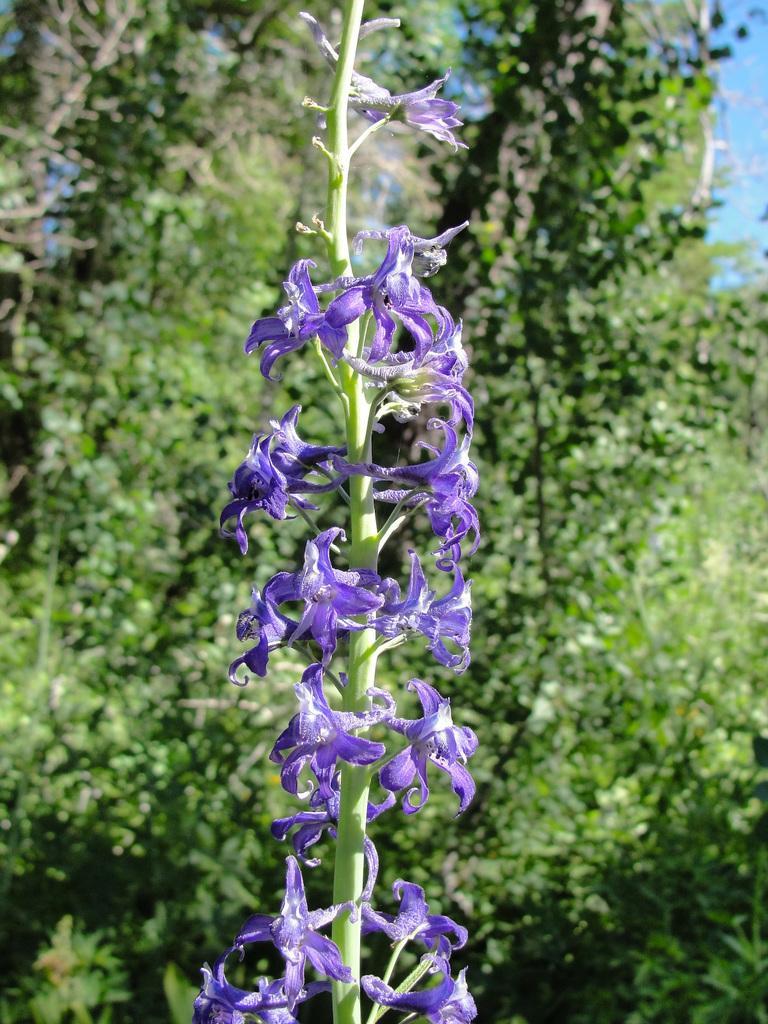Could you give a brief overview of what you see in this image? There are violet color flowers on a stem. In the background there are trees. 